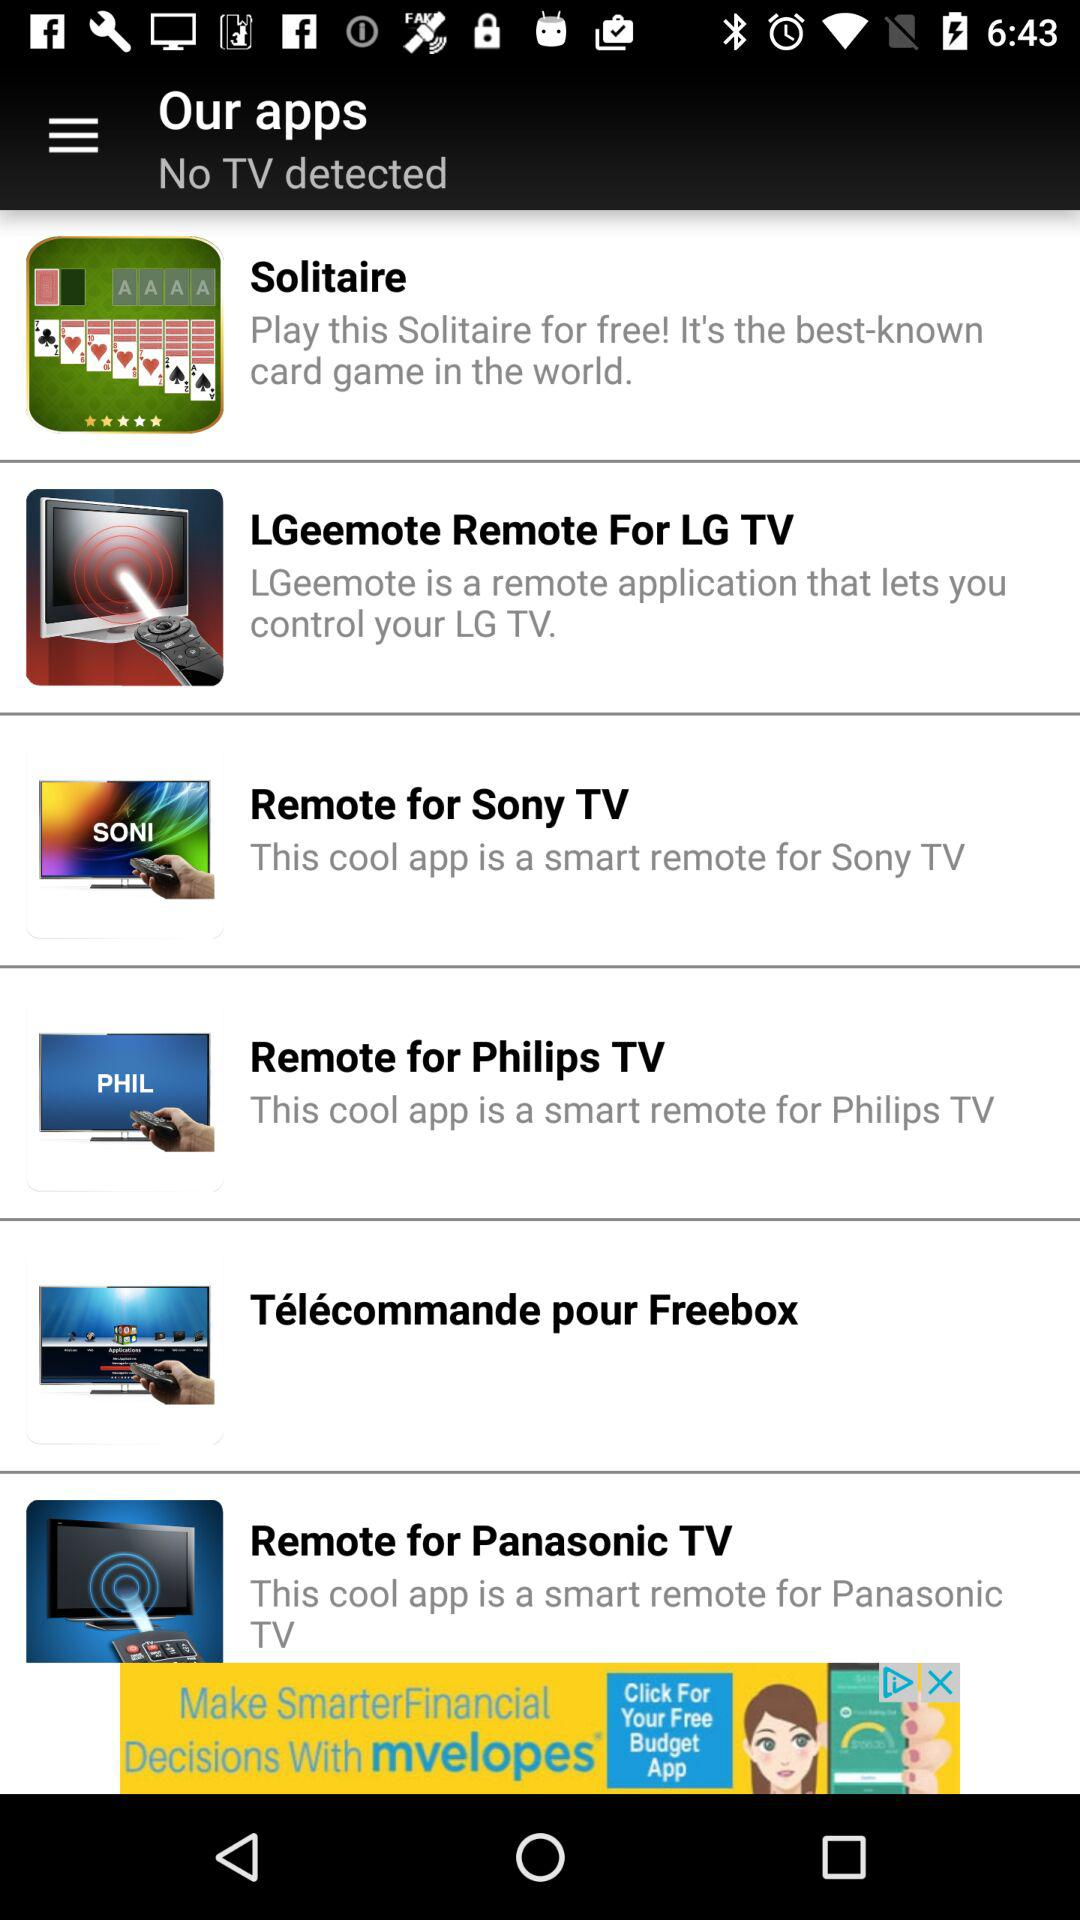How many apps are there for non-TVs?
Answer the question using a single word or phrase. 1 